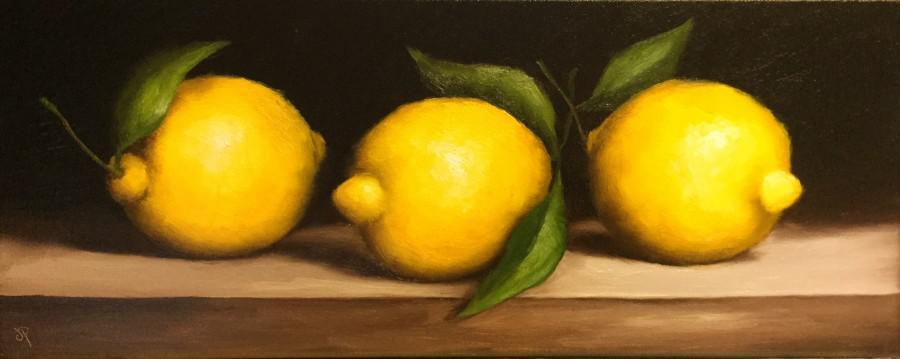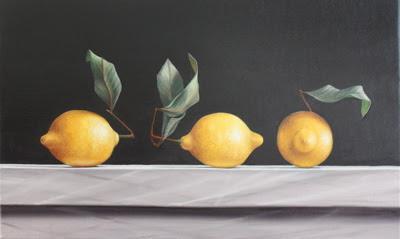The first image is the image on the left, the second image is the image on the right. Evaluate the accuracy of this statement regarding the images: "Some lemons are in a bowl.". Is it true? Answer yes or no. No. The first image is the image on the left, the second image is the image on the right. For the images displayed, is the sentence "There are three whole lemons lined up in a row in at least one of the images." factually correct? Answer yes or no. Yes. 